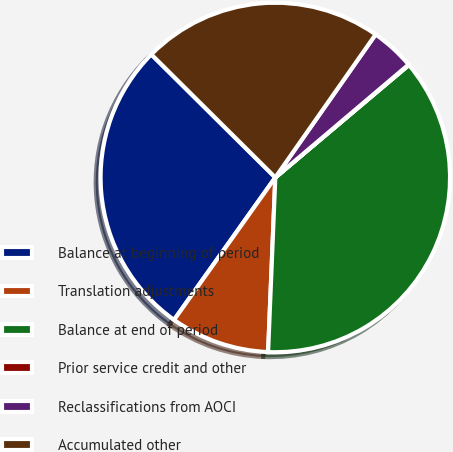Convert chart. <chart><loc_0><loc_0><loc_500><loc_500><pie_chart><fcel>Balance at beginning of period<fcel>Translation adjustments<fcel>Balance at end of period<fcel>Prior service credit and other<fcel>Reclassifications from AOCI<fcel>Accumulated other<nl><fcel>27.6%<fcel>9.18%<fcel>36.79%<fcel>0.05%<fcel>4.08%<fcel>22.29%<nl></chart> 